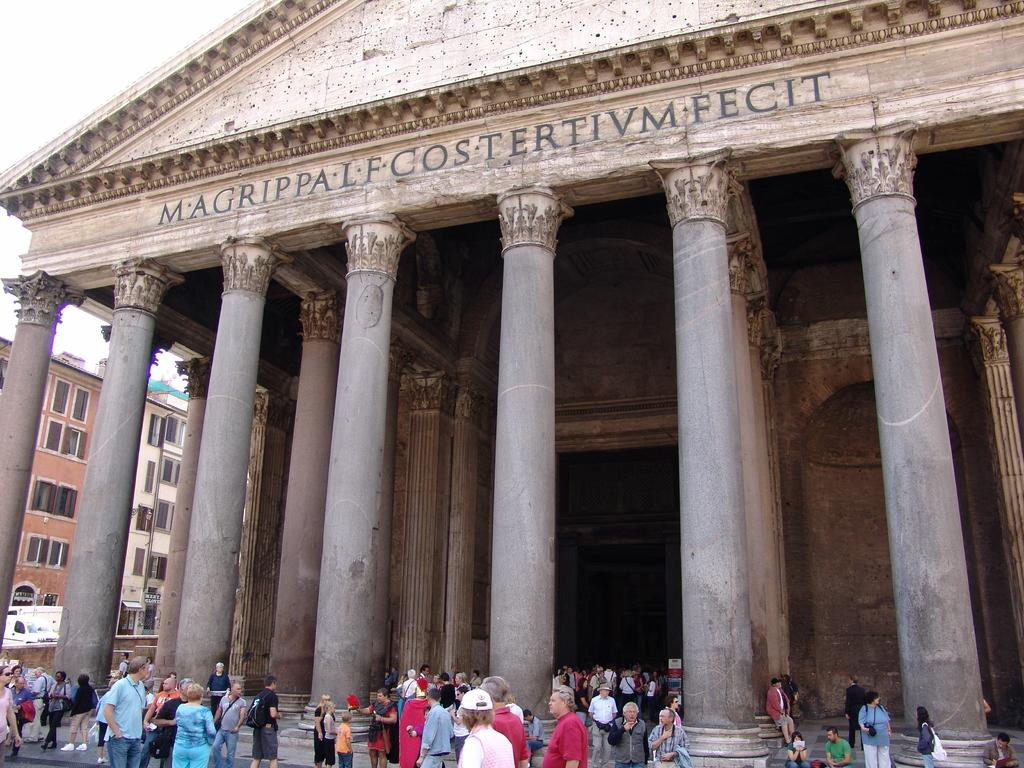What type of structures can be seen in the image? There are buildings in the image. Are there any living beings present in the image? Yes, there are people in the image. What feature can be observed on the buildings in the image? There are windows in the image. What part of the natural environment is visible in the image? The sky is visible in the image. How many cattle can be seen grazing in the aftermath of the storm in the image? There are no cattle or storm present in the image; it features buildings, people, windows, and the sky. What type of wash is being used to clean the windows in the image? There is no wash being used to clean the windows in the image; the windows are simply visible on the buildings. 